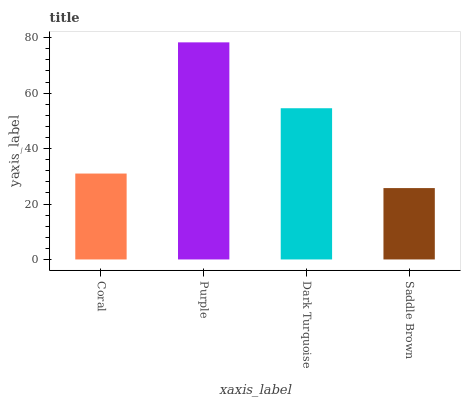Is Saddle Brown the minimum?
Answer yes or no. Yes. Is Purple the maximum?
Answer yes or no. Yes. Is Dark Turquoise the minimum?
Answer yes or no. No. Is Dark Turquoise the maximum?
Answer yes or no. No. Is Purple greater than Dark Turquoise?
Answer yes or no. Yes. Is Dark Turquoise less than Purple?
Answer yes or no. Yes. Is Dark Turquoise greater than Purple?
Answer yes or no. No. Is Purple less than Dark Turquoise?
Answer yes or no. No. Is Dark Turquoise the high median?
Answer yes or no. Yes. Is Coral the low median?
Answer yes or no. Yes. Is Saddle Brown the high median?
Answer yes or no. No. Is Purple the low median?
Answer yes or no. No. 